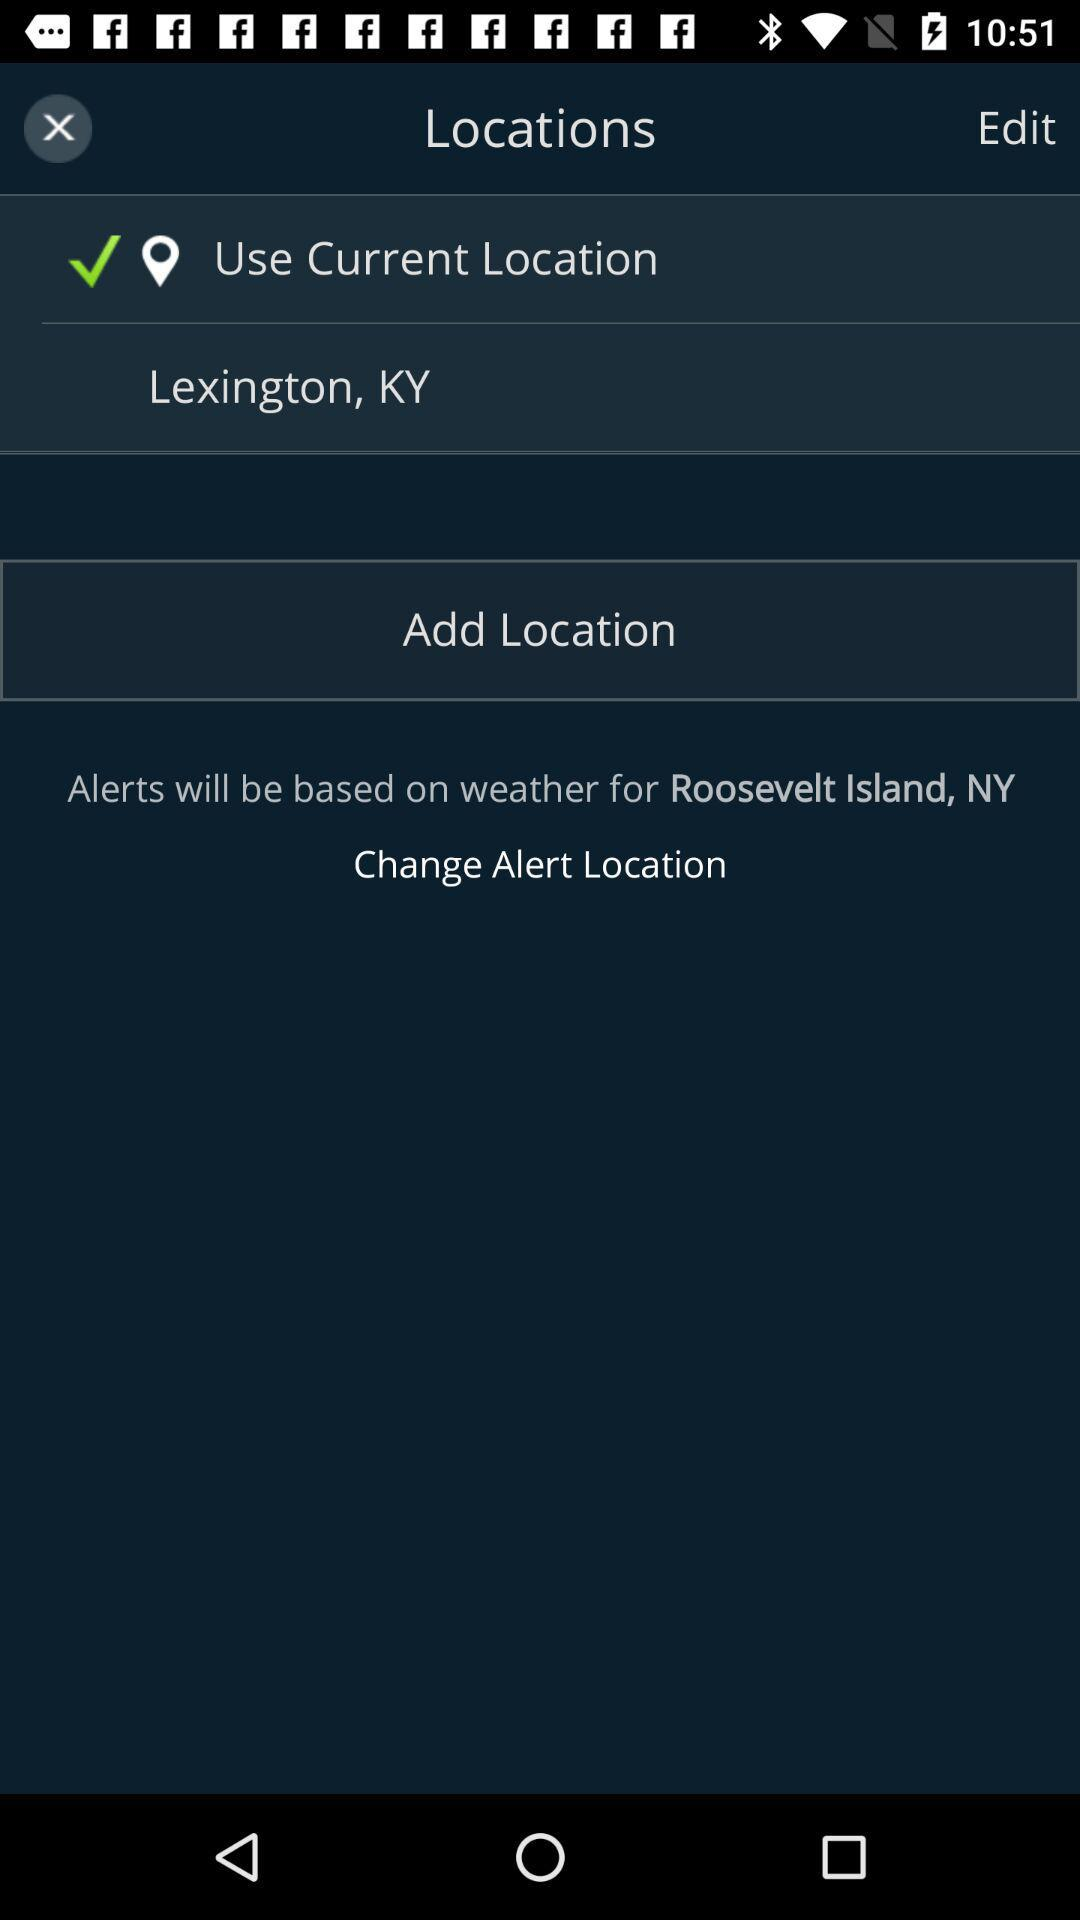How many locations are not checked?
Answer the question using a single word or phrase. 1 